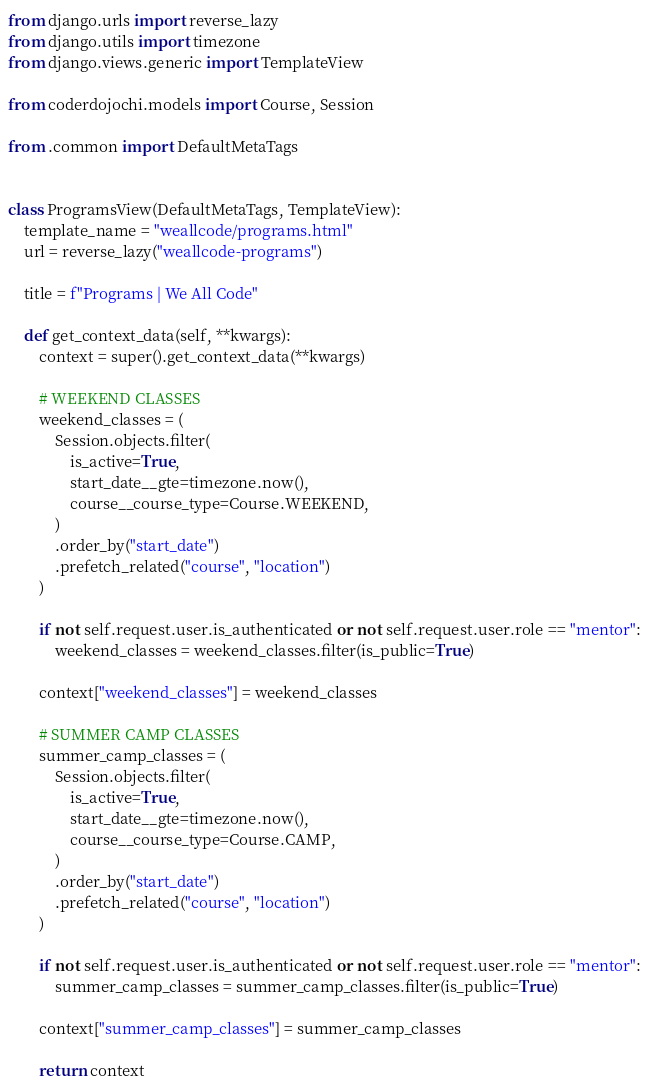Convert code to text. <code><loc_0><loc_0><loc_500><loc_500><_Python_>from django.urls import reverse_lazy
from django.utils import timezone
from django.views.generic import TemplateView

from coderdojochi.models import Course, Session

from .common import DefaultMetaTags


class ProgramsView(DefaultMetaTags, TemplateView):
    template_name = "weallcode/programs.html"
    url = reverse_lazy("weallcode-programs")

    title = f"Programs | We All Code"

    def get_context_data(self, **kwargs):
        context = super().get_context_data(**kwargs)

        # WEEKEND CLASSES
        weekend_classes = (
            Session.objects.filter(
                is_active=True,
                start_date__gte=timezone.now(),
                course__course_type=Course.WEEKEND,
            )
            .order_by("start_date")
            .prefetch_related("course", "location")
        )

        if not self.request.user.is_authenticated or not self.request.user.role == "mentor":
            weekend_classes = weekend_classes.filter(is_public=True)

        context["weekend_classes"] = weekend_classes

        # SUMMER CAMP CLASSES
        summer_camp_classes = (
            Session.objects.filter(
                is_active=True,
                start_date__gte=timezone.now(),
                course__course_type=Course.CAMP,
            )
            .order_by("start_date")
            .prefetch_related("course", "location")
        )

        if not self.request.user.is_authenticated or not self.request.user.role == "mentor":
            summer_camp_classes = summer_camp_classes.filter(is_public=True)

        context["summer_camp_classes"] = summer_camp_classes

        return context
</code> 